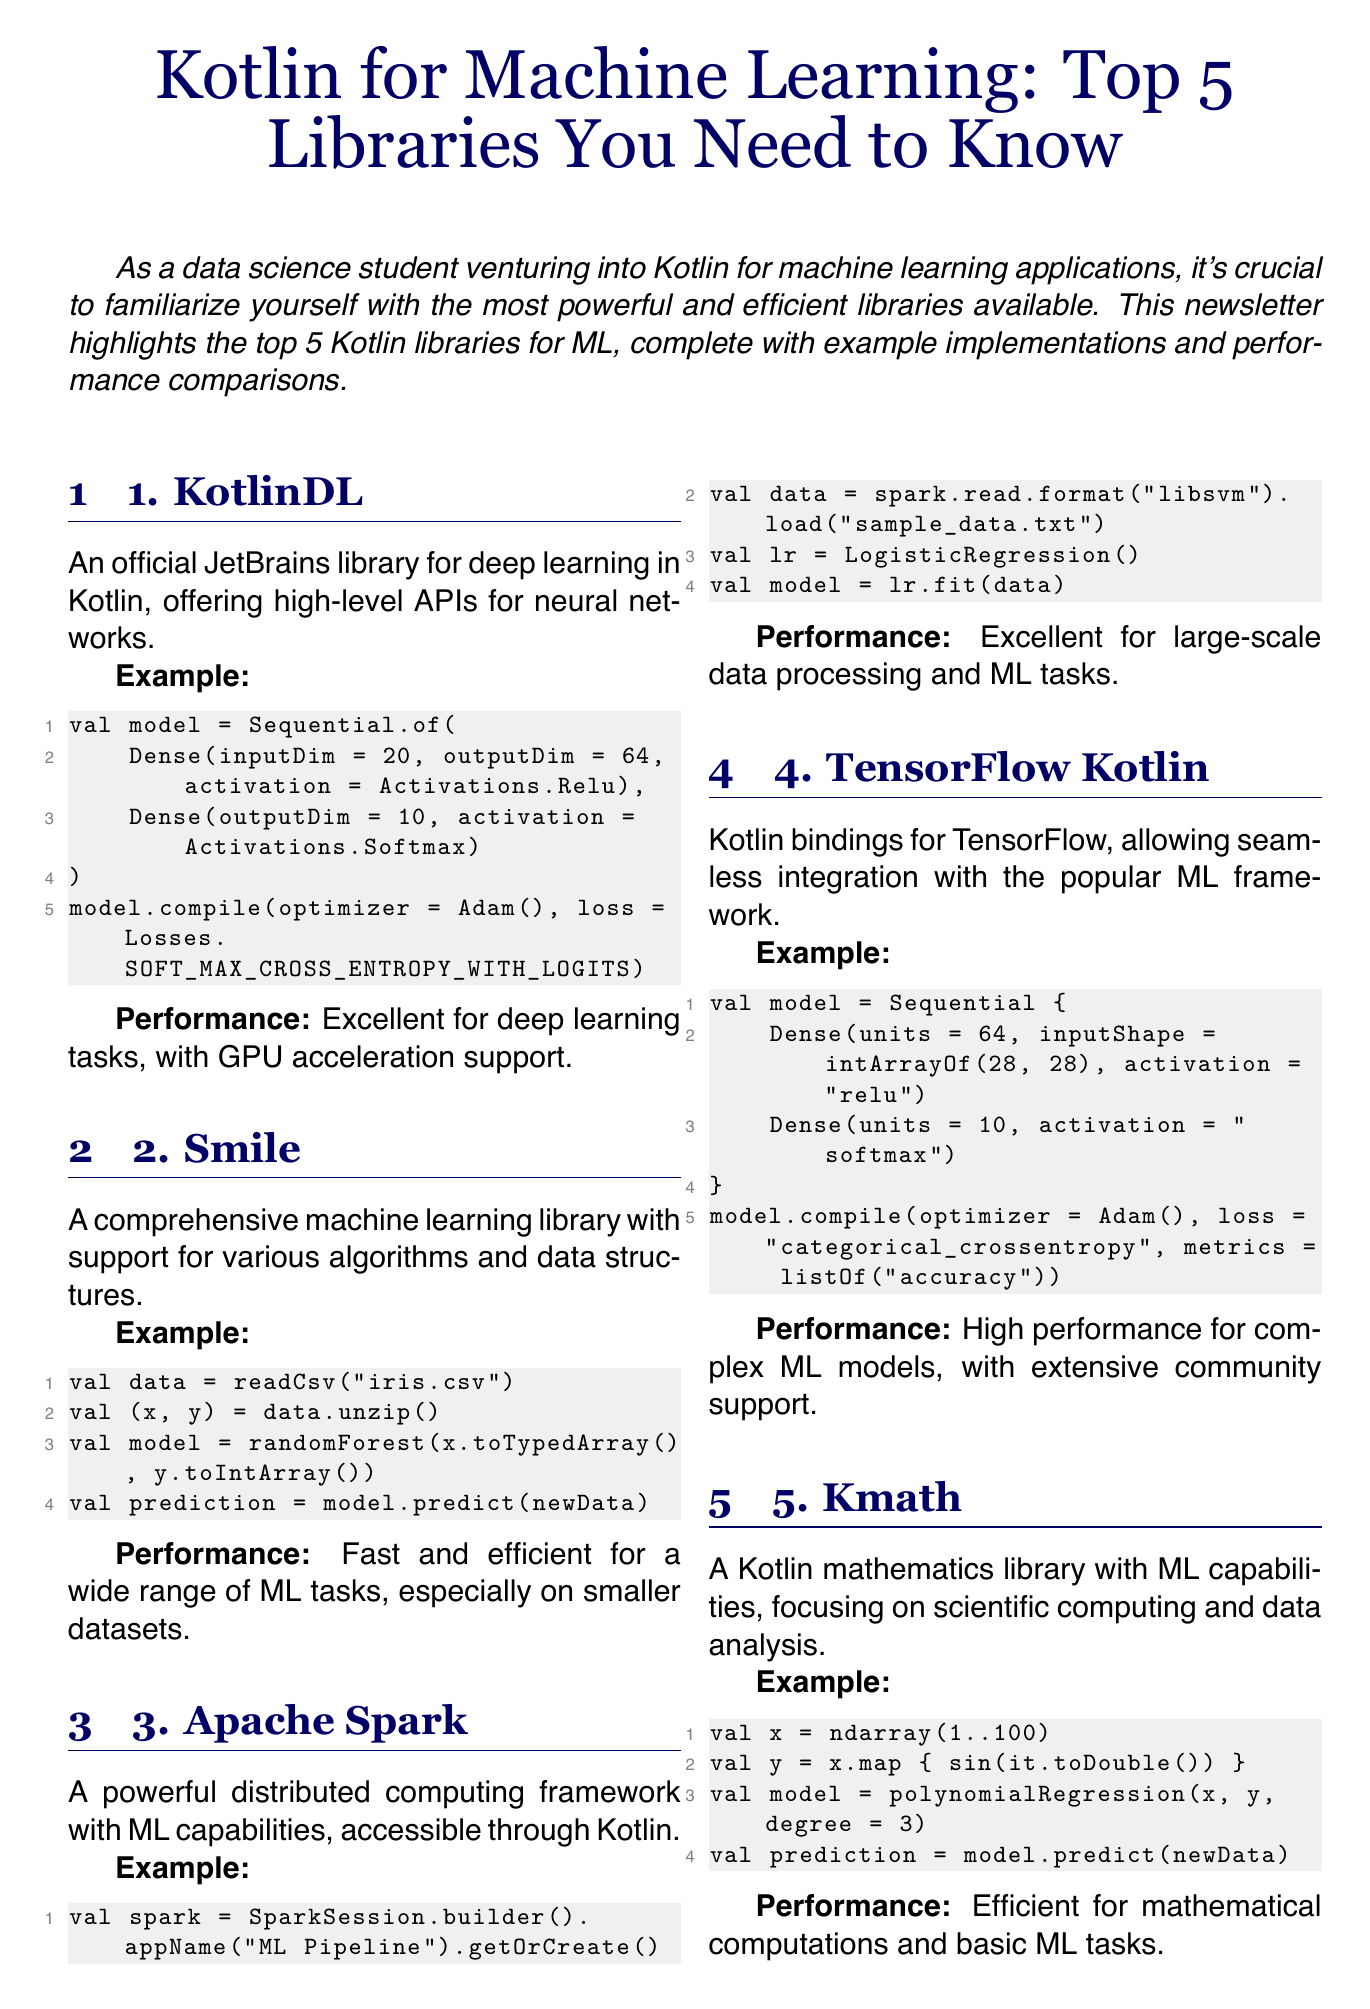What is the title of the newsletter? The title is clearly stated at the beginning of the document.
Answer: Kotlin for Machine Learning: Top 5 Libraries You Need to Know What library is developed by JetBrains? The library name is mentioned in the list format with related details, highlighting the developer information.
Answer: KotlinDL Which library is described as good for large-scale data processing? This information is gathered from the performance descriptions provided for each library.
Answer: Apache Spark How many libraries are presented in the newsletter? The introduction mentions that there are five libraries highlighted.
Answer: 5 What type of example is provided for Smile? By referencing the examples associated with each library, we can identify the provided format.
Answer: Random forest Which library is focused on mathematical computations? The libraries are specified with descriptions that explain their main areas of focus.
Answer: Kmath What is the performance note for TensorFlow Kotlin? The performance description gives insights into each library’s capabilities and community support.
Answer: High performance for complex ML models What is the call to action in the newsletter? The call to action is highlighted in the conclusion section prompting readers to take the next step.
Answer: Start by implementing a simple machine learning model What is the performance of KotlinDL? The performance information is summarized for each library to highlight their specific uses.
Answer: Excellent for deep learning tasks, with GPU acceleration support 